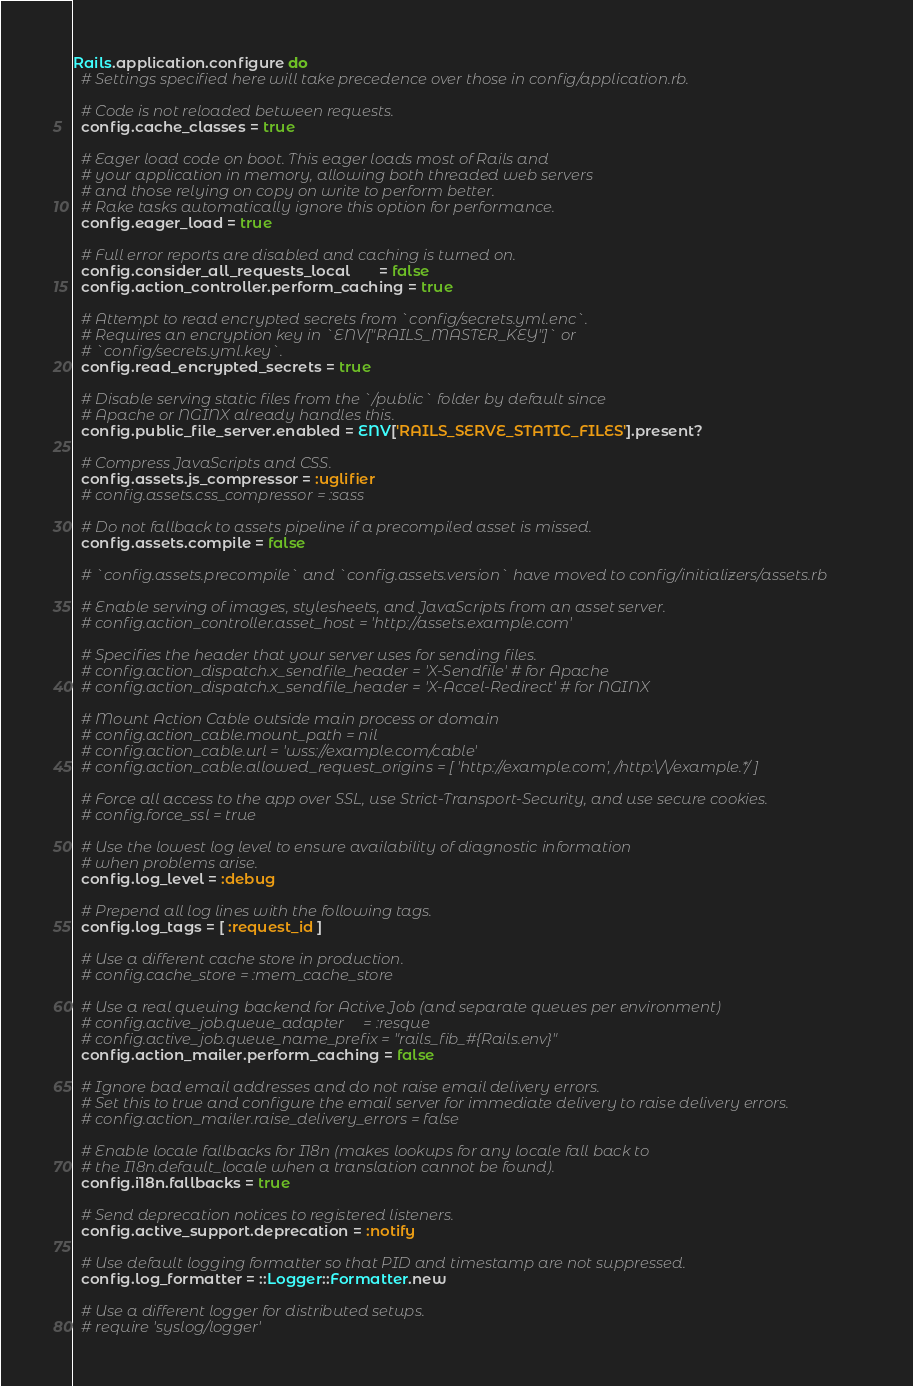<code> <loc_0><loc_0><loc_500><loc_500><_Ruby_>Rails.application.configure do
  # Settings specified here will take precedence over those in config/application.rb.

  # Code is not reloaded between requests.
  config.cache_classes = true

  # Eager load code on boot. This eager loads most of Rails and
  # your application in memory, allowing both threaded web servers
  # and those relying on copy on write to perform better.
  # Rake tasks automatically ignore this option for performance.
  config.eager_load = true

  # Full error reports are disabled and caching is turned on.
  config.consider_all_requests_local       = false
  config.action_controller.perform_caching = true

  # Attempt to read encrypted secrets from `config/secrets.yml.enc`.
  # Requires an encryption key in `ENV["RAILS_MASTER_KEY"]` or
  # `config/secrets.yml.key`.
  config.read_encrypted_secrets = true

  # Disable serving static files from the `/public` folder by default since
  # Apache or NGINX already handles this.
  config.public_file_server.enabled = ENV['RAILS_SERVE_STATIC_FILES'].present?

  # Compress JavaScripts and CSS.
  config.assets.js_compressor = :uglifier
  # config.assets.css_compressor = :sass

  # Do not fallback to assets pipeline if a precompiled asset is missed.
  config.assets.compile = false

  # `config.assets.precompile` and `config.assets.version` have moved to config/initializers/assets.rb

  # Enable serving of images, stylesheets, and JavaScripts from an asset server.
  # config.action_controller.asset_host = 'http://assets.example.com'

  # Specifies the header that your server uses for sending files.
  # config.action_dispatch.x_sendfile_header = 'X-Sendfile' # for Apache
  # config.action_dispatch.x_sendfile_header = 'X-Accel-Redirect' # for NGINX

  # Mount Action Cable outside main process or domain
  # config.action_cable.mount_path = nil
  # config.action_cable.url = 'wss://example.com/cable'
  # config.action_cable.allowed_request_origins = [ 'http://example.com', /http:\/\/example.*/ ]

  # Force all access to the app over SSL, use Strict-Transport-Security, and use secure cookies.
  # config.force_ssl = true

  # Use the lowest log level to ensure availability of diagnostic information
  # when problems arise.
  config.log_level = :debug

  # Prepend all log lines with the following tags.
  config.log_tags = [ :request_id ]

  # Use a different cache store in production.
  # config.cache_store = :mem_cache_store

  # Use a real queuing backend for Active Job (and separate queues per environment)
  # config.active_job.queue_adapter     = :resque
  # config.active_job.queue_name_prefix = "rails_fib_#{Rails.env}"
  config.action_mailer.perform_caching = false

  # Ignore bad email addresses and do not raise email delivery errors.
  # Set this to true and configure the email server for immediate delivery to raise delivery errors.
  # config.action_mailer.raise_delivery_errors = false

  # Enable locale fallbacks for I18n (makes lookups for any locale fall back to
  # the I18n.default_locale when a translation cannot be found).
  config.i18n.fallbacks = true

  # Send deprecation notices to registered listeners.
  config.active_support.deprecation = :notify

  # Use default logging formatter so that PID and timestamp are not suppressed.
  config.log_formatter = ::Logger::Formatter.new

  # Use a different logger for distributed setups.
  # require 'syslog/logger'</code> 